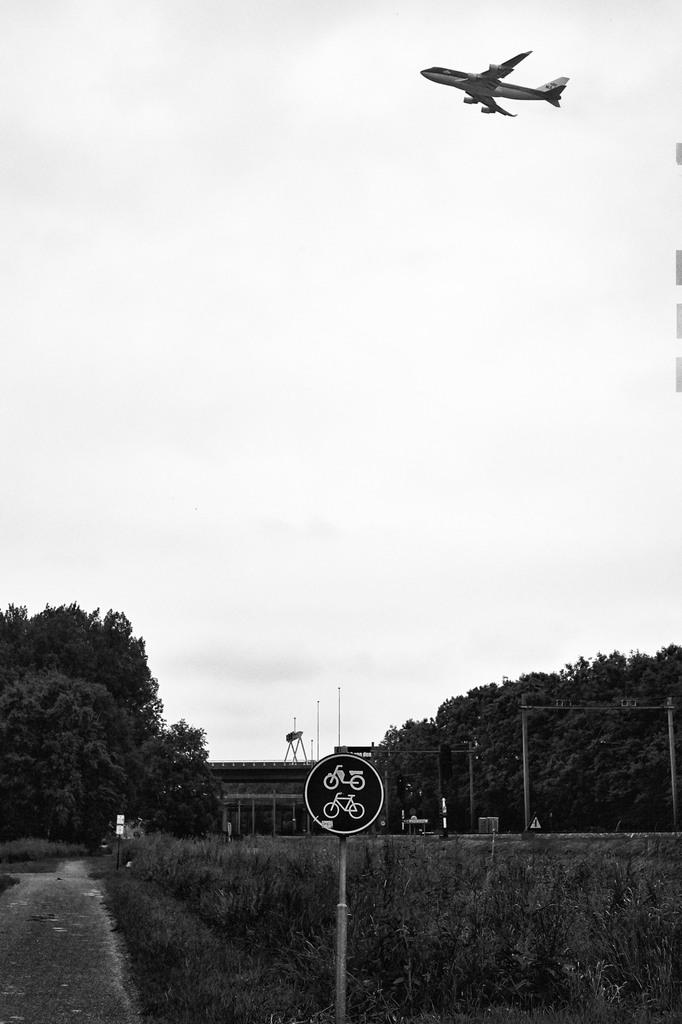What is attached to the pole in the image? There is a board attached to a pole in the image. What can be seen in the background of the image? There are trees and an aircraft in the background of the image. What is the color of the sky in the image? The sky is white in color. What type of mass is being measured on the board in the image? There is no indication of any mass being measured or present on the board in the image. 